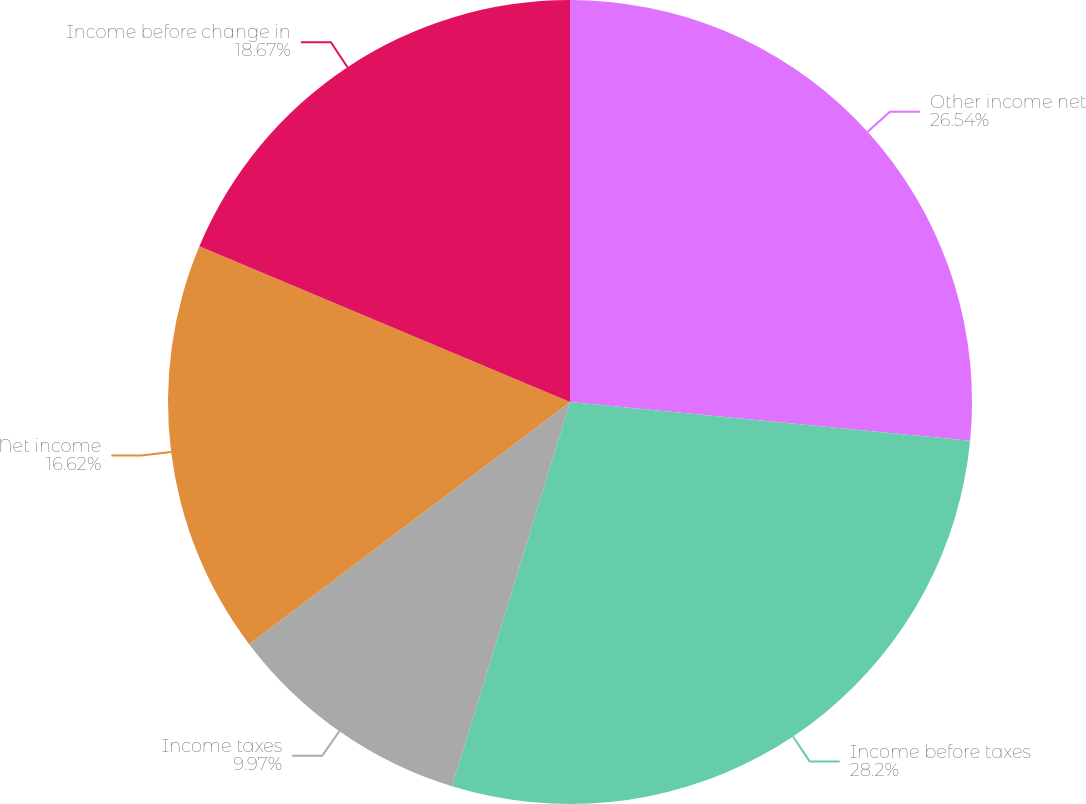<chart> <loc_0><loc_0><loc_500><loc_500><pie_chart><fcel>Other income net<fcel>Income before taxes<fcel>Income taxes<fcel>Net income<fcel>Income before change in<nl><fcel>26.54%<fcel>28.2%<fcel>9.97%<fcel>16.62%<fcel>18.67%<nl></chart> 